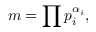Convert formula to latex. <formula><loc_0><loc_0><loc_500><loc_500>m = \prod p _ { i } ^ { \alpha _ { i } } ,</formula> 